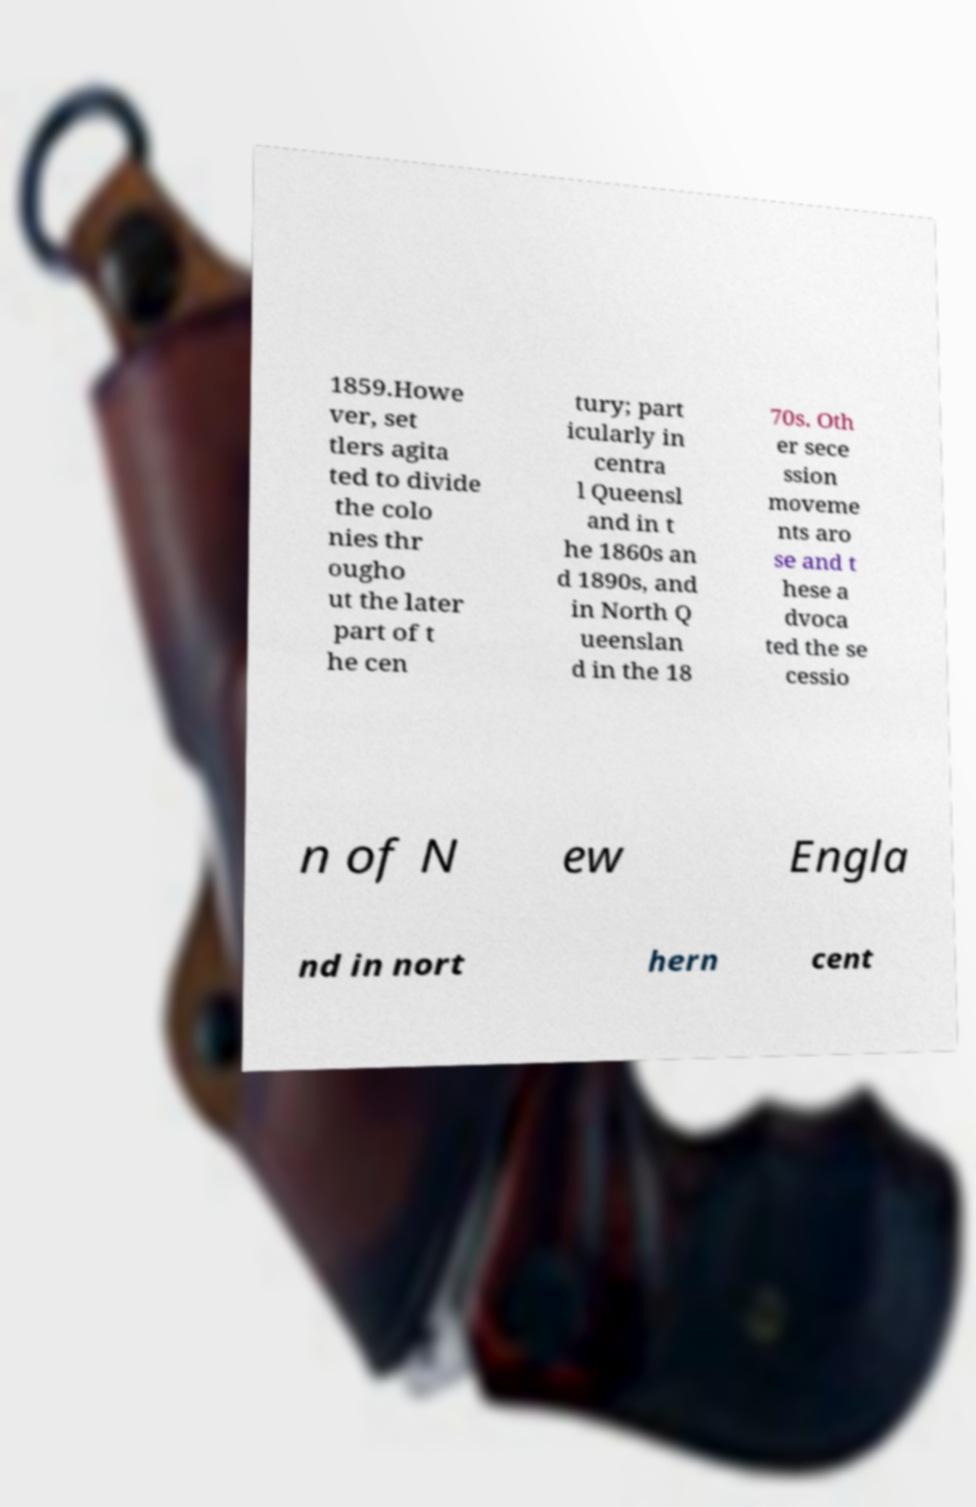Can you accurately transcribe the text from the provided image for me? 1859.Howe ver, set tlers agita ted to divide the colo nies thr ougho ut the later part of t he cen tury; part icularly in centra l Queensl and in t he 1860s an d 1890s, and in North Q ueenslan d in the 18 70s. Oth er sece ssion moveme nts aro se and t hese a dvoca ted the se cessio n of N ew Engla nd in nort hern cent 